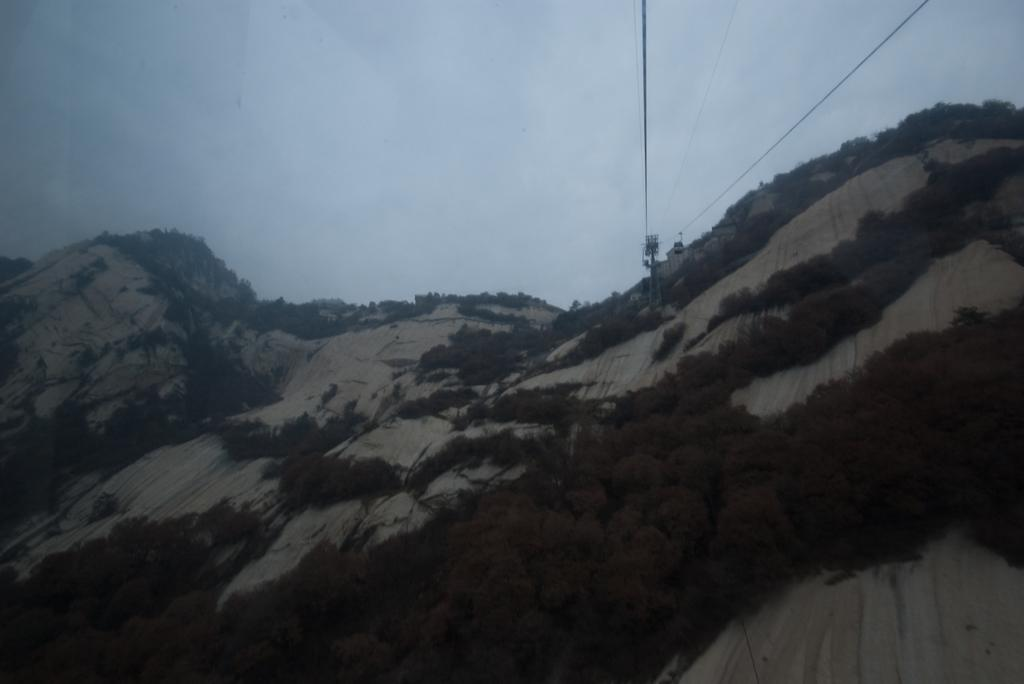What type of natural elements can be seen in the image? There are trees in the image. What geographical feature is present in the image? There is a hill in the image. What equipment is visible in the image? There are ropes and a ski lift in the image. What can be seen in the background of the image? The sky is visible in the background of the image. Where is the library located in the image? There is no library present in the image. What type of floor can be seen in the image? The image does not show a floor, as it appears to be an outdoor scene with trees, a hill, and a ski lift. 